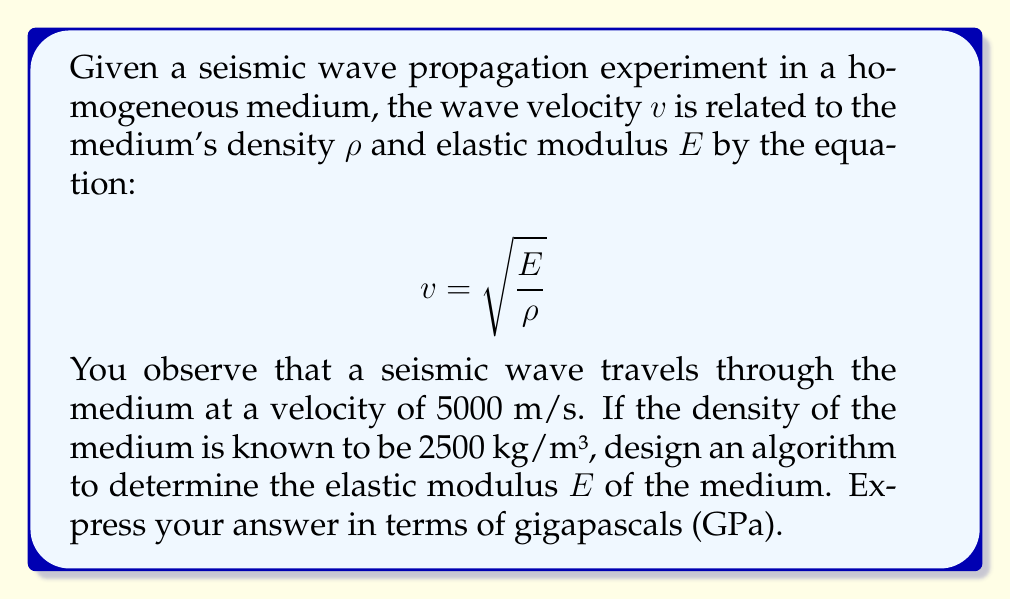What is the answer to this math problem? To solve this inverse problem and determine the elastic modulus $E$, we can follow these steps:

1. Identify the given information:
   - Wave velocity: $v = 5000$ m/s
   - Medium density: $\rho = 2500$ kg/m³

2. Rearrange the equation to solve for $E$:
   $$ v = \sqrt{\frac{E}{\rho}} $$
   $$ v^2 = \frac{E}{\rho} $$
   $$ E = \rho v^2 $$

3. Substitute the known values:
   $$ E = 2500 \text{ kg/m³} \cdot (5000 \text{ m/s})^2 $$

4. Perform the calculation:
   $$ E = 2500 \cdot 25,000,000 \text{ kg/(m·s²)} $$
   $$ E = 62,500,000,000 \text{ kg/(m·s²)} $$

5. Convert the result to GPa:
   - 1 Pa = 1 kg/(m·s²)
   - 1 GPa = 10⁹ Pa
   $$ E = \frac{62,500,000,000}{10^9} \text{ GPa} = 62.5 \text{ GPa} $$

The algorithm to solve this problem would involve these steps, with the key operation being the calculation of $E = \rho v^2$ and the subsequent unit conversion.
Answer: $E = 62.5$ GPa 